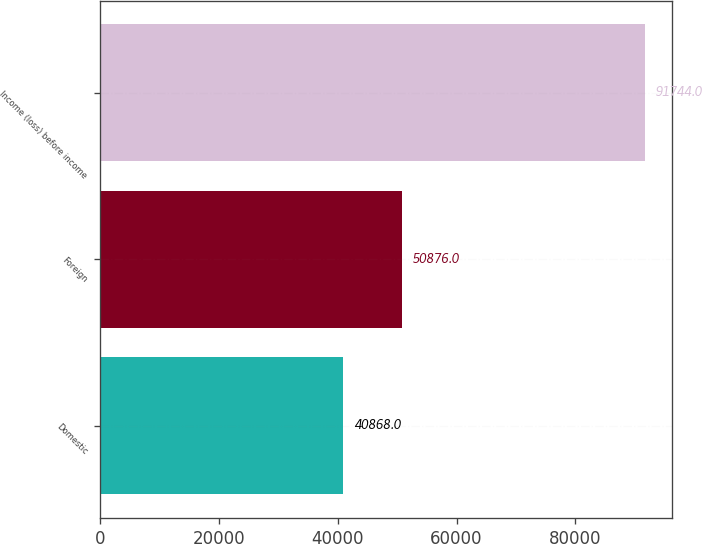Convert chart. <chart><loc_0><loc_0><loc_500><loc_500><bar_chart><fcel>Domestic<fcel>Foreign<fcel>Income (loss) before income<nl><fcel>40868<fcel>50876<fcel>91744<nl></chart> 